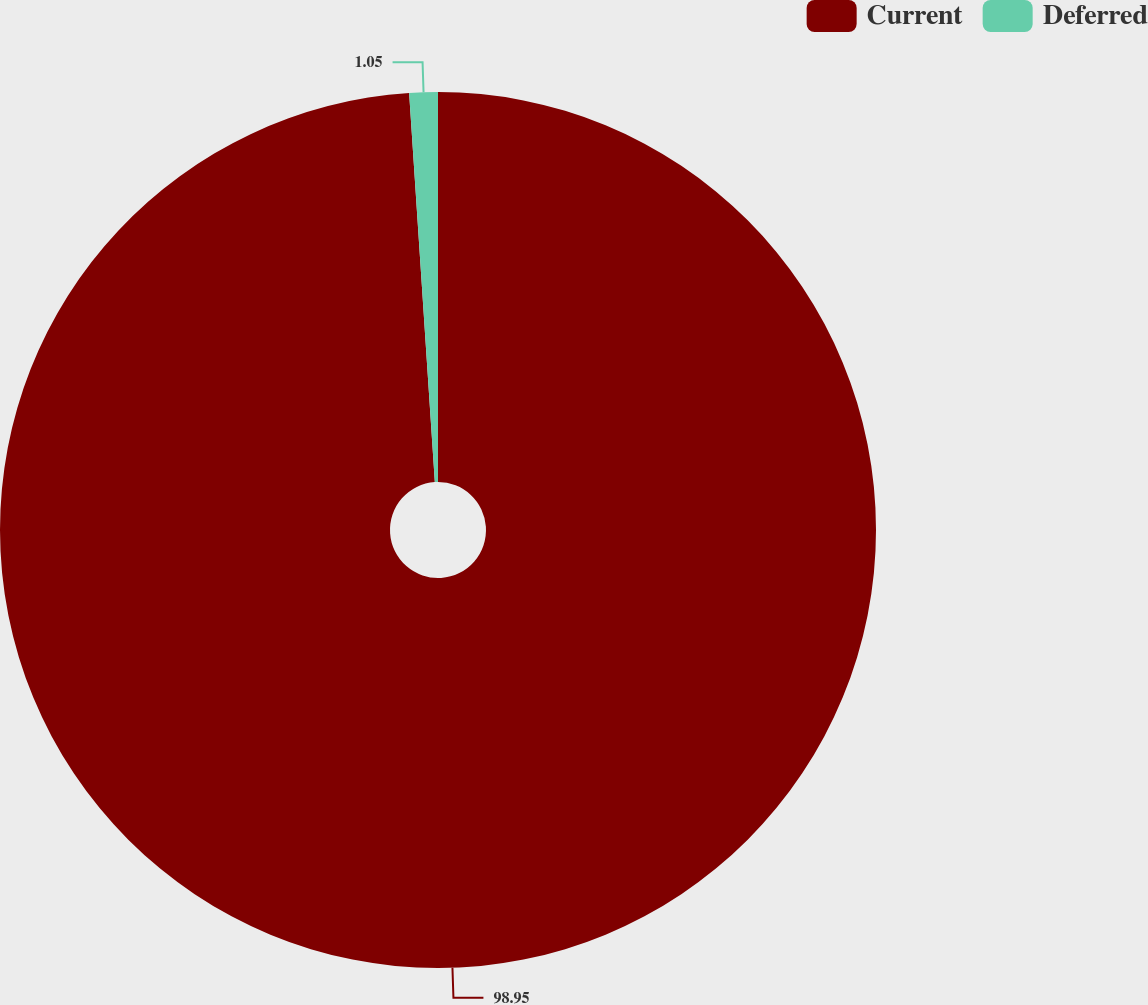<chart> <loc_0><loc_0><loc_500><loc_500><pie_chart><fcel>Current<fcel>Deferred<nl><fcel>98.95%<fcel>1.05%<nl></chart> 